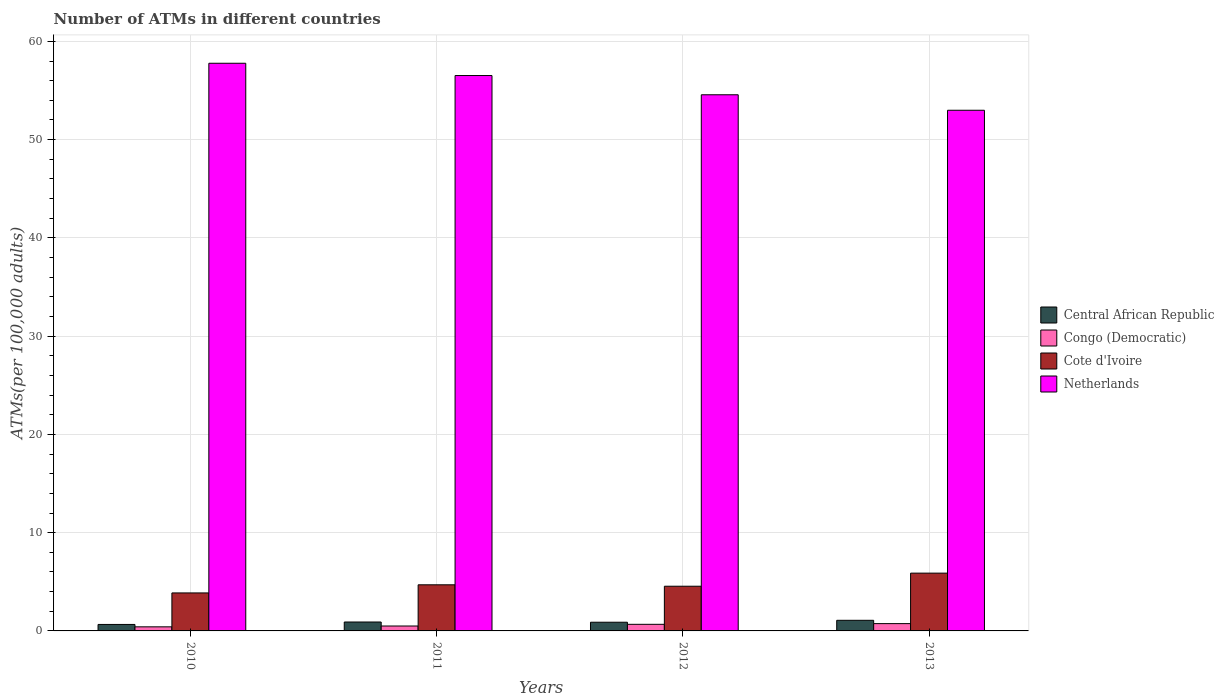How many different coloured bars are there?
Keep it short and to the point. 4. How many groups of bars are there?
Ensure brevity in your answer.  4. Are the number of bars per tick equal to the number of legend labels?
Offer a terse response. Yes. Are the number of bars on each tick of the X-axis equal?
Provide a short and direct response. Yes. How many bars are there on the 2nd tick from the right?
Offer a terse response. 4. What is the label of the 4th group of bars from the left?
Offer a terse response. 2013. In how many cases, is the number of bars for a given year not equal to the number of legend labels?
Provide a succinct answer. 0. What is the number of ATMs in Cote d'Ivoire in 2012?
Your answer should be very brief. 4.55. Across all years, what is the maximum number of ATMs in Congo (Democratic)?
Your answer should be very brief. 0.74. Across all years, what is the minimum number of ATMs in Cote d'Ivoire?
Provide a succinct answer. 3.87. In which year was the number of ATMs in Netherlands maximum?
Offer a very short reply. 2010. What is the total number of ATMs in Netherlands in the graph?
Your response must be concise. 221.85. What is the difference between the number of ATMs in Cote d'Ivoire in 2010 and that in 2013?
Ensure brevity in your answer.  -2.01. What is the difference between the number of ATMs in Cote d'Ivoire in 2011 and the number of ATMs in Netherlands in 2012?
Offer a terse response. -49.87. What is the average number of ATMs in Cote d'Ivoire per year?
Your answer should be very brief. 4.75. In the year 2011, what is the difference between the number of ATMs in Cote d'Ivoire and number of ATMs in Central African Republic?
Give a very brief answer. 3.79. In how many years, is the number of ATMs in Cote d'Ivoire greater than 14?
Provide a short and direct response. 0. What is the ratio of the number of ATMs in Central African Republic in 2010 to that in 2012?
Your answer should be very brief. 0.74. Is the number of ATMs in Netherlands in 2010 less than that in 2012?
Provide a short and direct response. No. What is the difference between the highest and the second highest number of ATMs in Congo (Democratic)?
Make the answer very short. 0.07. What is the difference between the highest and the lowest number of ATMs in Congo (Democratic)?
Your answer should be compact. 0.33. In how many years, is the number of ATMs in Cote d'Ivoire greater than the average number of ATMs in Cote d'Ivoire taken over all years?
Ensure brevity in your answer.  1. What does the 4th bar from the right in 2013 represents?
Your answer should be very brief. Central African Republic. Is it the case that in every year, the sum of the number of ATMs in Central African Republic and number of ATMs in Congo (Democratic) is greater than the number of ATMs in Netherlands?
Your answer should be very brief. No. How many years are there in the graph?
Your response must be concise. 4. What is the difference between two consecutive major ticks on the Y-axis?
Offer a very short reply. 10. Does the graph contain any zero values?
Make the answer very short. No. Where does the legend appear in the graph?
Ensure brevity in your answer.  Center right. What is the title of the graph?
Your answer should be compact. Number of ATMs in different countries. What is the label or title of the Y-axis?
Your answer should be very brief. ATMs(per 100,0 adults). What is the ATMs(per 100,000 adults) in Central African Republic in 2010?
Provide a succinct answer. 0.66. What is the ATMs(per 100,000 adults) in Congo (Democratic) in 2010?
Your response must be concise. 0.42. What is the ATMs(per 100,000 adults) of Cote d'Ivoire in 2010?
Offer a terse response. 3.87. What is the ATMs(per 100,000 adults) in Netherlands in 2010?
Give a very brief answer. 57.77. What is the ATMs(per 100,000 adults) in Central African Republic in 2011?
Ensure brevity in your answer.  0.91. What is the ATMs(per 100,000 adults) of Congo (Democratic) in 2011?
Provide a short and direct response. 0.5. What is the ATMs(per 100,000 adults) in Cote d'Ivoire in 2011?
Ensure brevity in your answer.  4.69. What is the ATMs(per 100,000 adults) in Netherlands in 2011?
Ensure brevity in your answer.  56.52. What is the ATMs(per 100,000 adults) of Central African Republic in 2012?
Offer a terse response. 0.88. What is the ATMs(per 100,000 adults) in Congo (Democratic) in 2012?
Your answer should be very brief. 0.67. What is the ATMs(per 100,000 adults) of Cote d'Ivoire in 2012?
Your answer should be very brief. 4.55. What is the ATMs(per 100,000 adults) of Netherlands in 2012?
Your response must be concise. 54.56. What is the ATMs(per 100,000 adults) of Central African Republic in 2013?
Offer a terse response. 1.08. What is the ATMs(per 100,000 adults) in Congo (Democratic) in 2013?
Your answer should be compact. 0.74. What is the ATMs(per 100,000 adults) of Cote d'Ivoire in 2013?
Provide a short and direct response. 5.88. What is the ATMs(per 100,000 adults) of Netherlands in 2013?
Provide a succinct answer. 52.99. Across all years, what is the maximum ATMs(per 100,000 adults) of Central African Republic?
Offer a very short reply. 1.08. Across all years, what is the maximum ATMs(per 100,000 adults) of Congo (Democratic)?
Offer a terse response. 0.74. Across all years, what is the maximum ATMs(per 100,000 adults) of Cote d'Ivoire?
Ensure brevity in your answer.  5.88. Across all years, what is the maximum ATMs(per 100,000 adults) of Netherlands?
Offer a terse response. 57.77. Across all years, what is the minimum ATMs(per 100,000 adults) in Central African Republic?
Your response must be concise. 0.66. Across all years, what is the minimum ATMs(per 100,000 adults) of Congo (Democratic)?
Your answer should be compact. 0.42. Across all years, what is the minimum ATMs(per 100,000 adults) in Cote d'Ivoire?
Give a very brief answer. 3.87. Across all years, what is the minimum ATMs(per 100,000 adults) of Netherlands?
Give a very brief answer. 52.99. What is the total ATMs(per 100,000 adults) of Central African Republic in the graph?
Your answer should be very brief. 3.53. What is the total ATMs(per 100,000 adults) of Congo (Democratic) in the graph?
Keep it short and to the point. 2.33. What is the total ATMs(per 100,000 adults) in Cote d'Ivoire in the graph?
Make the answer very short. 18.99. What is the total ATMs(per 100,000 adults) in Netherlands in the graph?
Make the answer very short. 221.85. What is the difference between the ATMs(per 100,000 adults) of Central African Republic in 2010 and that in 2011?
Your answer should be compact. -0.25. What is the difference between the ATMs(per 100,000 adults) of Congo (Democratic) in 2010 and that in 2011?
Keep it short and to the point. -0.08. What is the difference between the ATMs(per 100,000 adults) in Cote d'Ivoire in 2010 and that in 2011?
Your response must be concise. -0.83. What is the difference between the ATMs(per 100,000 adults) in Netherlands in 2010 and that in 2011?
Offer a very short reply. 1.25. What is the difference between the ATMs(per 100,000 adults) of Central African Republic in 2010 and that in 2012?
Make the answer very short. -0.23. What is the difference between the ATMs(per 100,000 adults) of Congo (Democratic) in 2010 and that in 2012?
Ensure brevity in your answer.  -0.26. What is the difference between the ATMs(per 100,000 adults) of Cote d'Ivoire in 2010 and that in 2012?
Provide a succinct answer. -0.68. What is the difference between the ATMs(per 100,000 adults) of Netherlands in 2010 and that in 2012?
Ensure brevity in your answer.  3.21. What is the difference between the ATMs(per 100,000 adults) of Central African Republic in 2010 and that in 2013?
Offer a very short reply. -0.42. What is the difference between the ATMs(per 100,000 adults) in Congo (Democratic) in 2010 and that in 2013?
Give a very brief answer. -0.33. What is the difference between the ATMs(per 100,000 adults) of Cote d'Ivoire in 2010 and that in 2013?
Give a very brief answer. -2.01. What is the difference between the ATMs(per 100,000 adults) of Netherlands in 2010 and that in 2013?
Give a very brief answer. 4.78. What is the difference between the ATMs(per 100,000 adults) of Central African Republic in 2011 and that in 2012?
Keep it short and to the point. 0.02. What is the difference between the ATMs(per 100,000 adults) in Congo (Democratic) in 2011 and that in 2012?
Your answer should be compact. -0.17. What is the difference between the ATMs(per 100,000 adults) of Cote d'Ivoire in 2011 and that in 2012?
Provide a succinct answer. 0.15. What is the difference between the ATMs(per 100,000 adults) of Netherlands in 2011 and that in 2012?
Your answer should be compact. 1.96. What is the difference between the ATMs(per 100,000 adults) in Central African Republic in 2011 and that in 2013?
Offer a terse response. -0.17. What is the difference between the ATMs(per 100,000 adults) of Congo (Democratic) in 2011 and that in 2013?
Your answer should be compact. -0.24. What is the difference between the ATMs(per 100,000 adults) in Cote d'Ivoire in 2011 and that in 2013?
Your answer should be very brief. -1.19. What is the difference between the ATMs(per 100,000 adults) in Netherlands in 2011 and that in 2013?
Your answer should be compact. 3.53. What is the difference between the ATMs(per 100,000 adults) in Central African Republic in 2012 and that in 2013?
Make the answer very short. -0.2. What is the difference between the ATMs(per 100,000 adults) of Congo (Democratic) in 2012 and that in 2013?
Your response must be concise. -0.07. What is the difference between the ATMs(per 100,000 adults) of Cote d'Ivoire in 2012 and that in 2013?
Ensure brevity in your answer.  -1.33. What is the difference between the ATMs(per 100,000 adults) of Netherlands in 2012 and that in 2013?
Give a very brief answer. 1.58. What is the difference between the ATMs(per 100,000 adults) in Central African Republic in 2010 and the ATMs(per 100,000 adults) in Congo (Democratic) in 2011?
Give a very brief answer. 0.16. What is the difference between the ATMs(per 100,000 adults) of Central African Republic in 2010 and the ATMs(per 100,000 adults) of Cote d'Ivoire in 2011?
Offer a terse response. -4.04. What is the difference between the ATMs(per 100,000 adults) in Central African Republic in 2010 and the ATMs(per 100,000 adults) in Netherlands in 2011?
Your answer should be very brief. -55.86. What is the difference between the ATMs(per 100,000 adults) in Congo (Democratic) in 2010 and the ATMs(per 100,000 adults) in Cote d'Ivoire in 2011?
Provide a short and direct response. -4.28. What is the difference between the ATMs(per 100,000 adults) of Congo (Democratic) in 2010 and the ATMs(per 100,000 adults) of Netherlands in 2011?
Give a very brief answer. -56.11. What is the difference between the ATMs(per 100,000 adults) in Cote d'Ivoire in 2010 and the ATMs(per 100,000 adults) in Netherlands in 2011?
Provide a succinct answer. -52.66. What is the difference between the ATMs(per 100,000 adults) of Central African Republic in 2010 and the ATMs(per 100,000 adults) of Congo (Democratic) in 2012?
Provide a succinct answer. -0.01. What is the difference between the ATMs(per 100,000 adults) of Central African Republic in 2010 and the ATMs(per 100,000 adults) of Cote d'Ivoire in 2012?
Ensure brevity in your answer.  -3.89. What is the difference between the ATMs(per 100,000 adults) in Central African Republic in 2010 and the ATMs(per 100,000 adults) in Netherlands in 2012?
Your answer should be very brief. -53.91. What is the difference between the ATMs(per 100,000 adults) in Congo (Democratic) in 2010 and the ATMs(per 100,000 adults) in Cote d'Ivoire in 2012?
Provide a succinct answer. -4.13. What is the difference between the ATMs(per 100,000 adults) in Congo (Democratic) in 2010 and the ATMs(per 100,000 adults) in Netherlands in 2012?
Give a very brief answer. -54.15. What is the difference between the ATMs(per 100,000 adults) of Cote d'Ivoire in 2010 and the ATMs(per 100,000 adults) of Netherlands in 2012?
Your response must be concise. -50.7. What is the difference between the ATMs(per 100,000 adults) of Central African Republic in 2010 and the ATMs(per 100,000 adults) of Congo (Democratic) in 2013?
Ensure brevity in your answer.  -0.09. What is the difference between the ATMs(per 100,000 adults) in Central African Republic in 2010 and the ATMs(per 100,000 adults) in Cote d'Ivoire in 2013?
Provide a succinct answer. -5.22. What is the difference between the ATMs(per 100,000 adults) in Central African Republic in 2010 and the ATMs(per 100,000 adults) in Netherlands in 2013?
Give a very brief answer. -52.33. What is the difference between the ATMs(per 100,000 adults) of Congo (Democratic) in 2010 and the ATMs(per 100,000 adults) of Cote d'Ivoire in 2013?
Your response must be concise. -5.47. What is the difference between the ATMs(per 100,000 adults) in Congo (Democratic) in 2010 and the ATMs(per 100,000 adults) in Netherlands in 2013?
Offer a terse response. -52.57. What is the difference between the ATMs(per 100,000 adults) in Cote d'Ivoire in 2010 and the ATMs(per 100,000 adults) in Netherlands in 2013?
Make the answer very short. -49.12. What is the difference between the ATMs(per 100,000 adults) in Central African Republic in 2011 and the ATMs(per 100,000 adults) in Congo (Democratic) in 2012?
Give a very brief answer. 0.24. What is the difference between the ATMs(per 100,000 adults) in Central African Republic in 2011 and the ATMs(per 100,000 adults) in Cote d'Ivoire in 2012?
Offer a terse response. -3.64. What is the difference between the ATMs(per 100,000 adults) in Central African Republic in 2011 and the ATMs(per 100,000 adults) in Netherlands in 2012?
Give a very brief answer. -53.66. What is the difference between the ATMs(per 100,000 adults) in Congo (Democratic) in 2011 and the ATMs(per 100,000 adults) in Cote d'Ivoire in 2012?
Your response must be concise. -4.05. What is the difference between the ATMs(per 100,000 adults) in Congo (Democratic) in 2011 and the ATMs(per 100,000 adults) in Netherlands in 2012?
Make the answer very short. -54.06. What is the difference between the ATMs(per 100,000 adults) of Cote d'Ivoire in 2011 and the ATMs(per 100,000 adults) of Netherlands in 2012?
Give a very brief answer. -49.87. What is the difference between the ATMs(per 100,000 adults) of Central African Republic in 2011 and the ATMs(per 100,000 adults) of Congo (Democratic) in 2013?
Provide a succinct answer. 0.16. What is the difference between the ATMs(per 100,000 adults) in Central African Republic in 2011 and the ATMs(per 100,000 adults) in Cote d'Ivoire in 2013?
Provide a succinct answer. -4.97. What is the difference between the ATMs(per 100,000 adults) in Central African Republic in 2011 and the ATMs(per 100,000 adults) in Netherlands in 2013?
Keep it short and to the point. -52.08. What is the difference between the ATMs(per 100,000 adults) in Congo (Democratic) in 2011 and the ATMs(per 100,000 adults) in Cote d'Ivoire in 2013?
Provide a succinct answer. -5.38. What is the difference between the ATMs(per 100,000 adults) of Congo (Democratic) in 2011 and the ATMs(per 100,000 adults) of Netherlands in 2013?
Your answer should be very brief. -52.49. What is the difference between the ATMs(per 100,000 adults) in Cote d'Ivoire in 2011 and the ATMs(per 100,000 adults) in Netherlands in 2013?
Your answer should be very brief. -48.3. What is the difference between the ATMs(per 100,000 adults) in Central African Republic in 2012 and the ATMs(per 100,000 adults) in Congo (Democratic) in 2013?
Offer a terse response. 0.14. What is the difference between the ATMs(per 100,000 adults) of Central African Republic in 2012 and the ATMs(per 100,000 adults) of Cote d'Ivoire in 2013?
Make the answer very short. -5. What is the difference between the ATMs(per 100,000 adults) of Central African Republic in 2012 and the ATMs(per 100,000 adults) of Netherlands in 2013?
Your answer should be compact. -52.1. What is the difference between the ATMs(per 100,000 adults) in Congo (Democratic) in 2012 and the ATMs(per 100,000 adults) in Cote d'Ivoire in 2013?
Give a very brief answer. -5.21. What is the difference between the ATMs(per 100,000 adults) in Congo (Democratic) in 2012 and the ATMs(per 100,000 adults) in Netherlands in 2013?
Keep it short and to the point. -52.32. What is the difference between the ATMs(per 100,000 adults) in Cote d'Ivoire in 2012 and the ATMs(per 100,000 adults) in Netherlands in 2013?
Give a very brief answer. -48.44. What is the average ATMs(per 100,000 adults) in Central African Republic per year?
Give a very brief answer. 0.88. What is the average ATMs(per 100,000 adults) in Congo (Democratic) per year?
Make the answer very short. 0.58. What is the average ATMs(per 100,000 adults) of Cote d'Ivoire per year?
Give a very brief answer. 4.75. What is the average ATMs(per 100,000 adults) of Netherlands per year?
Your answer should be very brief. 55.46. In the year 2010, what is the difference between the ATMs(per 100,000 adults) in Central African Republic and ATMs(per 100,000 adults) in Congo (Democratic)?
Keep it short and to the point. 0.24. In the year 2010, what is the difference between the ATMs(per 100,000 adults) in Central African Republic and ATMs(per 100,000 adults) in Cote d'Ivoire?
Your answer should be very brief. -3.21. In the year 2010, what is the difference between the ATMs(per 100,000 adults) in Central African Republic and ATMs(per 100,000 adults) in Netherlands?
Make the answer very short. -57.11. In the year 2010, what is the difference between the ATMs(per 100,000 adults) in Congo (Democratic) and ATMs(per 100,000 adults) in Cote d'Ivoire?
Make the answer very short. -3.45. In the year 2010, what is the difference between the ATMs(per 100,000 adults) in Congo (Democratic) and ATMs(per 100,000 adults) in Netherlands?
Your response must be concise. -57.36. In the year 2010, what is the difference between the ATMs(per 100,000 adults) in Cote d'Ivoire and ATMs(per 100,000 adults) in Netherlands?
Give a very brief answer. -53.91. In the year 2011, what is the difference between the ATMs(per 100,000 adults) in Central African Republic and ATMs(per 100,000 adults) in Congo (Democratic)?
Provide a succinct answer. 0.41. In the year 2011, what is the difference between the ATMs(per 100,000 adults) of Central African Republic and ATMs(per 100,000 adults) of Cote d'Ivoire?
Your response must be concise. -3.79. In the year 2011, what is the difference between the ATMs(per 100,000 adults) of Central African Republic and ATMs(per 100,000 adults) of Netherlands?
Make the answer very short. -55.62. In the year 2011, what is the difference between the ATMs(per 100,000 adults) in Congo (Democratic) and ATMs(per 100,000 adults) in Cote d'Ivoire?
Make the answer very short. -4.19. In the year 2011, what is the difference between the ATMs(per 100,000 adults) in Congo (Democratic) and ATMs(per 100,000 adults) in Netherlands?
Offer a terse response. -56.02. In the year 2011, what is the difference between the ATMs(per 100,000 adults) in Cote d'Ivoire and ATMs(per 100,000 adults) in Netherlands?
Offer a very short reply. -51.83. In the year 2012, what is the difference between the ATMs(per 100,000 adults) in Central African Republic and ATMs(per 100,000 adults) in Congo (Democratic)?
Keep it short and to the point. 0.21. In the year 2012, what is the difference between the ATMs(per 100,000 adults) of Central African Republic and ATMs(per 100,000 adults) of Cote d'Ivoire?
Your response must be concise. -3.66. In the year 2012, what is the difference between the ATMs(per 100,000 adults) of Central African Republic and ATMs(per 100,000 adults) of Netherlands?
Offer a terse response. -53.68. In the year 2012, what is the difference between the ATMs(per 100,000 adults) in Congo (Democratic) and ATMs(per 100,000 adults) in Cote d'Ivoire?
Give a very brief answer. -3.88. In the year 2012, what is the difference between the ATMs(per 100,000 adults) of Congo (Democratic) and ATMs(per 100,000 adults) of Netherlands?
Your response must be concise. -53.89. In the year 2012, what is the difference between the ATMs(per 100,000 adults) of Cote d'Ivoire and ATMs(per 100,000 adults) of Netherlands?
Offer a terse response. -50.02. In the year 2013, what is the difference between the ATMs(per 100,000 adults) in Central African Republic and ATMs(per 100,000 adults) in Congo (Democratic)?
Provide a succinct answer. 0.34. In the year 2013, what is the difference between the ATMs(per 100,000 adults) of Central African Republic and ATMs(per 100,000 adults) of Cote d'Ivoire?
Your answer should be very brief. -4.8. In the year 2013, what is the difference between the ATMs(per 100,000 adults) of Central African Republic and ATMs(per 100,000 adults) of Netherlands?
Make the answer very short. -51.91. In the year 2013, what is the difference between the ATMs(per 100,000 adults) of Congo (Democratic) and ATMs(per 100,000 adults) of Cote d'Ivoire?
Offer a terse response. -5.14. In the year 2013, what is the difference between the ATMs(per 100,000 adults) of Congo (Democratic) and ATMs(per 100,000 adults) of Netherlands?
Keep it short and to the point. -52.24. In the year 2013, what is the difference between the ATMs(per 100,000 adults) in Cote d'Ivoire and ATMs(per 100,000 adults) in Netherlands?
Provide a succinct answer. -47.11. What is the ratio of the ATMs(per 100,000 adults) of Central African Republic in 2010 to that in 2011?
Your answer should be compact. 0.73. What is the ratio of the ATMs(per 100,000 adults) in Congo (Democratic) in 2010 to that in 2011?
Your answer should be compact. 0.83. What is the ratio of the ATMs(per 100,000 adults) in Cote d'Ivoire in 2010 to that in 2011?
Give a very brief answer. 0.82. What is the ratio of the ATMs(per 100,000 adults) of Netherlands in 2010 to that in 2011?
Give a very brief answer. 1.02. What is the ratio of the ATMs(per 100,000 adults) in Central African Republic in 2010 to that in 2012?
Make the answer very short. 0.74. What is the ratio of the ATMs(per 100,000 adults) in Congo (Democratic) in 2010 to that in 2012?
Ensure brevity in your answer.  0.62. What is the ratio of the ATMs(per 100,000 adults) in Cote d'Ivoire in 2010 to that in 2012?
Keep it short and to the point. 0.85. What is the ratio of the ATMs(per 100,000 adults) in Netherlands in 2010 to that in 2012?
Your response must be concise. 1.06. What is the ratio of the ATMs(per 100,000 adults) of Central African Republic in 2010 to that in 2013?
Your response must be concise. 0.61. What is the ratio of the ATMs(per 100,000 adults) of Congo (Democratic) in 2010 to that in 2013?
Give a very brief answer. 0.56. What is the ratio of the ATMs(per 100,000 adults) of Cote d'Ivoire in 2010 to that in 2013?
Provide a succinct answer. 0.66. What is the ratio of the ATMs(per 100,000 adults) of Netherlands in 2010 to that in 2013?
Offer a terse response. 1.09. What is the ratio of the ATMs(per 100,000 adults) in Central African Republic in 2011 to that in 2012?
Offer a very short reply. 1.03. What is the ratio of the ATMs(per 100,000 adults) of Congo (Democratic) in 2011 to that in 2012?
Provide a succinct answer. 0.75. What is the ratio of the ATMs(per 100,000 adults) in Cote d'Ivoire in 2011 to that in 2012?
Your answer should be compact. 1.03. What is the ratio of the ATMs(per 100,000 adults) of Netherlands in 2011 to that in 2012?
Ensure brevity in your answer.  1.04. What is the ratio of the ATMs(per 100,000 adults) of Central African Republic in 2011 to that in 2013?
Give a very brief answer. 0.84. What is the ratio of the ATMs(per 100,000 adults) of Congo (Democratic) in 2011 to that in 2013?
Provide a succinct answer. 0.67. What is the ratio of the ATMs(per 100,000 adults) of Cote d'Ivoire in 2011 to that in 2013?
Ensure brevity in your answer.  0.8. What is the ratio of the ATMs(per 100,000 adults) in Netherlands in 2011 to that in 2013?
Offer a terse response. 1.07. What is the ratio of the ATMs(per 100,000 adults) in Central African Republic in 2012 to that in 2013?
Give a very brief answer. 0.82. What is the ratio of the ATMs(per 100,000 adults) of Congo (Democratic) in 2012 to that in 2013?
Your answer should be very brief. 0.9. What is the ratio of the ATMs(per 100,000 adults) in Cote d'Ivoire in 2012 to that in 2013?
Your response must be concise. 0.77. What is the ratio of the ATMs(per 100,000 adults) in Netherlands in 2012 to that in 2013?
Give a very brief answer. 1.03. What is the difference between the highest and the second highest ATMs(per 100,000 adults) in Central African Republic?
Ensure brevity in your answer.  0.17. What is the difference between the highest and the second highest ATMs(per 100,000 adults) of Congo (Democratic)?
Your response must be concise. 0.07. What is the difference between the highest and the second highest ATMs(per 100,000 adults) in Cote d'Ivoire?
Provide a succinct answer. 1.19. What is the difference between the highest and the second highest ATMs(per 100,000 adults) in Netherlands?
Your answer should be very brief. 1.25. What is the difference between the highest and the lowest ATMs(per 100,000 adults) in Central African Republic?
Provide a short and direct response. 0.42. What is the difference between the highest and the lowest ATMs(per 100,000 adults) in Congo (Democratic)?
Give a very brief answer. 0.33. What is the difference between the highest and the lowest ATMs(per 100,000 adults) of Cote d'Ivoire?
Your answer should be compact. 2.01. What is the difference between the highest and the lowest ATMs(per 100,000 adults) in Netherlands?
Provide a short and direct response. 4.78. 